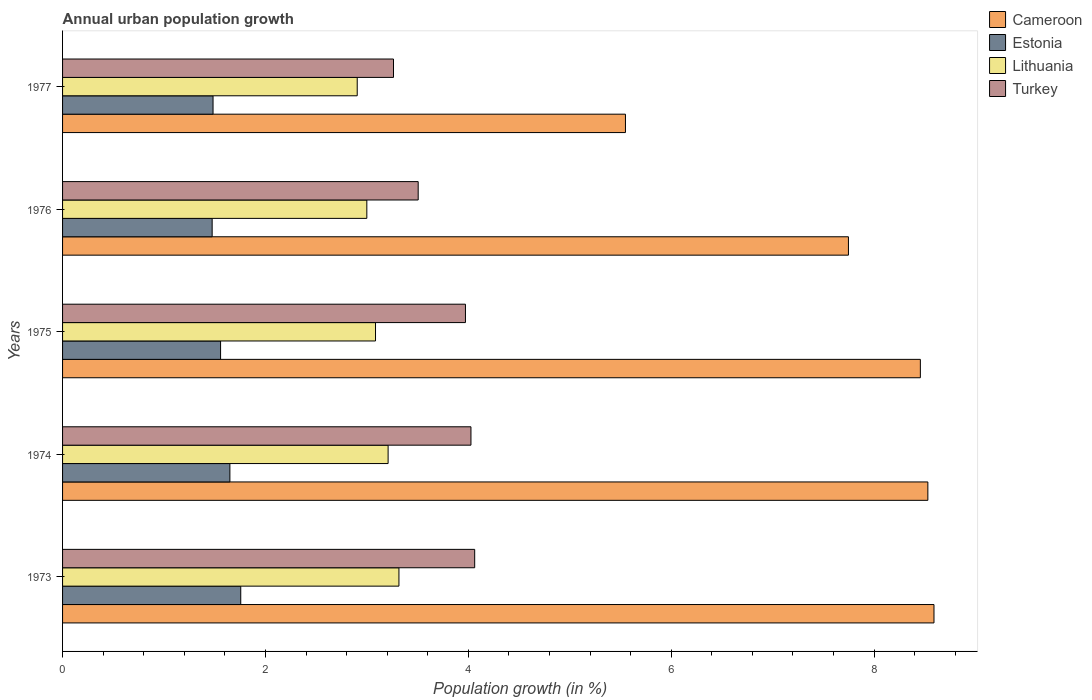How many different coloured bars are there?
Provide a short and direct response. 4. How many groups of bars are there?
Your answer should be very brief. 5. Are the number of bars per tick equal to the number of legend labels?
Your answer should be compact. Yes. How many bars are there on the 3rd tick from the top?
Your answer should be compact. 4. How many bars are there on the 4th tick from the bottom?
Ensure brevity in your answer.  4. What is the label of the 5th group of bars from the top?
Your answer should be compact. 1973. What is the percentage of urban population growth in Estonia in 1976?
Your response must be concise. 1.47. Across all years, what is the maximum percentage of urban population growth in Estonia?
Give a very brief answer. 1.76. Across all years, what is the minimum percentage of urban population growth in Lithuania?
Offer a very short reply. 2.9. In which year was the percentage of urban population growth in Turkey maximum?
Provide a short and direct response. 1973. What is the total percentage of urban population growth in Lithuania in the graph?
Offer a terse response. 15.52. What is the difference between the percentage of urban population growth in Cameroon in 1976 and that in 1977?
Your answer should be compact. 2.2. What is the difference between the percentage of urban population growth in Estonia in 1977 and the percentage of urban population growth in Turkey in 1975?
Your answer should be very brief. -2.49. What is the average percentage of urban population growth in Lithuania per year?
Ensure brevity in your answer.  3.1. In the year 1975, what is the difference between the percentage of urban population growth in Lithuania and percentage of urban population growth in Cameroon?
Your answer should be very brief. -5.37. In how many years, is the percentage of urban population growth in Lithuania greater than 2.4 %?
Offer a terse response. 5. What is the ratio of the percentage of urban population growth in Lithuania in 1974 to that in 1976?
Your response must be concise. 1.07. Is the percentage of urban population growth in Lithuania in 1975 less than that in 1977?
Your answer should be very brief. No. What is the difference between the highest and the second highest percentage of urban population growth in Estonia?
Keep it short and to the point. 0.11. What is the difference between the highest and the lowest percentage of urban population growth in Cameroon?
Keep it short and to the point. 3.04. In how many years, is the percentage of urban population growth in Lithuania greater than the average percentage of urban population growth in Lithuania taken over all years?
Your response must be concise. 2. Is the sum of the percentage of urban population growth in Lithuania in 1975 and 1977 greater than the maximum percentage of urban population growth in Turkey across all years?
Offer a terse response. Yes. Is it the case that in every year, the sum of the percentage of urban population growth in Lithuania and percentage of urban population growth in Cameroon is greater than the sum of percentage of urban population growth in Estonia and percentage of urban population growth in Turkey?
Offer a very short reply. No. What does the 3rd bar from the top in 1975 represents?
Provide a short and direct response. Estonia. What does the 1st bar from the bottom in 1974 represents?
Your answer should be compact. Cameroon. How many bars are there?
Keep it short and to the point. 20. Does the graph contain grids?
Ensure brevity in your answer.  No. What is the title of the graph?
Keep it short and to the point. Annual urban population growth. Does "Luxembourg" appear as one of the legend labels in the graph?
Ensure brevity in your answer.  No. What is the label or title of the X-axis?
Keep it short and to the point. Population growth (in %). What is the label or title of the Y-axis?
Give a very brief answer. Years. What is the Population growth (in %) in Cameroon in 1973?
Keep it short and to the point. 8.59. What is the Population growth (in %) in Estonia in 1973?
Provide a succinct answer. 1.76. What is the Population growth (in %) in Lithuania in 1973?
Offer a very short reply. 3.32. What is the Population growth (in %) in Turkey in 1973?
Offer a terse response. 4.06. What is the Population growth (in %) of Cameroon in 1974?
Your answer should be compact. 8.53. What is the Population growth (in %) in Estonia in 1974?
Provide a succinct answer. 1.65. What is the Population growth (in %) of Lithuania in 1974?
Provide a succinct answer. 3.21. What is the Population growth (in %) in Turkey in 1974?
Ensure brevity in your answer.  4.03. What is the Population growth (in %) in Cameroon in 1975?
Make the answer very short. 8.46. What is the Population growth (in %) of Estonia in 1975?
Provide a succinct answer. 1.56. What is the Population growth (in %) in Lithuania in 1975?
Give a very brief answer. 3.09. What is the Population growth (in %) of Turkey in 1975?
Keep it short and to the point. 3.97. What is the Population growth (in %) of Cameroon in 1976?
Provide a short and direct response. 7.75. What is the Population growth (in %) of Estonia in 1976?
Make the answer very short. 1.47. What is the Population growth (in %) of Lithuania in 1976?
Provide a succinct answer. 3. What is the Population growth (in %) of Turkey in 1976?
Your response must be concise. 3.51. What is the Population growth (in %) of Cameroon in 1977?
Offer a terse response. 5.55. What is the Population growth (in %) in Estonia in 1977?
Make the answer very short. 1.48. What is the Population growth (in %) of Lithuania in 1977?
Ensure brevity in your answer.  2.9. What is the Population growth (in %) in Turkey in 1977?
Offer a very short reply. 3.26. Across all years, what is the maximum Population growth (in %) of Cameroon?
Make the answer very short. 8.59. Across all years, what is the maximum Population growth (in %) of Estonia?
Offer a terse response. 1.76. Across all years, what is the maximum Population growth (in %) of Lithuania?
Provide a short and direct response. 3.32. Across all years, what is the maximum Population growth (in %) of Turkey?
Your answer should be compact. 4.06. Across all years, what is the minimum Population growth (in %) of Cameroon?
Your response must be concise. 5.55. Across all years, what is the minimum Population growth (in %) of Estonia?
Make the answer very short. 1.47. Across all years, what is the minimum Population growth (in %) of Lithuania?
Your response must be concise. 2.9. Across all years, what is the minimum Population growth (in %) of Turkey?
Give a very brief answer. 3.26. What is the total Population growth (in %) of Cameroon in the graph?
Ensure brevity in your answer.  38.87. What is the total Population growth (in %) in Estonia in the graph?
Provide a short and direct response. 7.92. What is the total Population growth (in %) of Lithuania in the graph?
Give a very brief answer. 15.52. What is the total Population growth (in %) in Turkey in the graph?
Give a very brief answer. 18.83. What is the difference between the Population growth (in %) of Cameroon in 1973 and that in 1974?
Offer a terse response. 0.06. What is the difference between the Population growth (in %) in Estonia in 1973 and that in 1974?
Give a very brief answer. 0.11. What is the difference between the Population growth (in %) of Lithuania in 1973 and that in 1974?
Your response must be concise. 0.11. What is the difference between the Population growth (in %) of Turkey in 1973 and that in 1974?
Your answer should be compact. 0.04. What is the difference between the Population growth (in %) of Cameroon in 1973 and that in 1975?
Your answer should be very brief. 0.13. What is the difference between the Population growth (in %) in Estonia in 1973 and that in 1975?
Your answer should be compact. 0.2. What is the difference between the Population growth (in %) in Lithuania in 1973 and that in 1975?
Make the answer very short. 0.23. What is the difference between the Population growth (in %) of Turkey in 1973 and that in 1975?
Offer a terse response. 0.09. What is the difference between the Population growth (in %) in Cameroon in 1973 and that in 1976?
Make the answer very short. 0.84. What is the difference between the Population growth (in %) in Estonia in 1973 and that in 1976?
Your response must be concise. 0.28. What is the difference between the Population growth (in %) in Lithuania in 1973 and that in 1976?
Offer a terse response. 0.32. What is the difference between the Population growth (in %) of Turkey in 1973 and that in 1976?
Keep it short and to the point. 0.56. What is the difference between the Population growth (in %) in Cameroon in 1973 and that in 1977?
Keep it short and to the point. 3.04. What is the difference between the Population growth (in %) of Estonia in 1973 and that in 1977?
Offer a very short reply. 0.27. What is the difference between the Population growth (in %) of Lithuania in 1973 and that in 1977?
Offer a terse response. 0.41. What is the difference between the Population growth (in %) in Turkey in 1973 and that in 1977?
Offer a terse response. 0.8. What is the difference between the Population growth (in %) of Cameroon in 1974 and that in 1975?
Offer a very short reply. 0.07. What is the difference between the Population growth (in %) of Estonia in 1974 and that in 1975?
Offer a very short reply. 0.09. What is the difference between the Population growth (in %) in Lithuania in 1974 and that in 1975?
Provide a short and direct response. 0.12. What is the difference between the Population growth (in %) of Turkey in 1974 and that in 1975?
Make the answer very short. 0.05. What is the difference between the Population growth (in %) of Cameroon in 1974 and that in 1976?
Offer a very short reply. 0.78. What is the difference between the Population growth (in %) of Estonia in 1974 and that in 1976?
Provide a succinct answer. 0.17. What is the difference between the Population growth (in %) in Lithuania in 1974 and that in 1976?
Provide a succinct answer. 0.21. What is the difference between the Population growth (in %) of Turkey in 1974 and that in 1976?
Make the answer very short. 0.52. What is the difference between the Population growth (in %) of Cameroon in 1974 and that in 1977?
Your response must be concise. 2.98. What is the difference between the Population growth (in %) of Estonia in 1974 and that in 1977?
Your response must be concise. 0.17. What is the difference between the Population growth (in %) in Lithuania in 1974 and that in 1977?
Provide a succinct answer. 0.3. What is the difference between the Population growth (in %) of Turkey in 1974 and that in 1977?
Your answer should be very brief. 0.76. What is the difference between the Population growth (in %) in Cameroon in 1975 and that in 1976?
Your answer should be very brief. 0.71. What is the difference between the Population growth (in %) of Estonia in 1975 and that in 1976?
Your response must be concise. 0.08. What is the difference between the Population growth (in %) in Lithuania in 1975 and that in 1976?
Offer a terse response. 0.09. What is the difference between the Population growth (in %) in Turkey in 1975 and that in 1976?
Ensure brevity in your answer.  0.47. What is the difference between the Population growth (in %) in Cameroon in 1975 and that in 1977?
Offer a very short reply. 2.91. What is the difference between the Population growth (in %) of Estonia in 1975 and that in 1977?
Your answer should be very brief. 0.07. What is the difference between the Population growth (in %) of Lithuania in 1975 and that in 1977?
Keep it short and to the point. 0.18. What is the difference between the Population growth (in %) of Turkey in 1975 and that in 1977?
Provide a short and direct response. 0.71. What is the difference between the Population growth (in %) of Cameroon in 1976 and that in 1977?
Provide a short and direct response. 2.2. What is the difference between the Population growth (in %) in Estonia in 1976 and that in 1977?
Give a very brief answer. -0.01. What is the difference between the Population growth (in %) in Lithuania in 1976 and that in 1977?
Offer a very short reply. 0.09. What is the difference between the Population growth (in %) in Turkey in 1976 and that in 1977?
Make the answer very short. 0.24. What is the difference between the Population growth (in %) in Cameroon in 1973 and the Population growth (in %) in Estonia in 1974?
Ensure brevity in your answer.  6.94. What is the difference between the Population growth (in %) of Cameroon in 1973 and the Population growth (in %) of Lithuania in 1974?
Ensure brevity in your answer.  5.38. What is the difference between the Population growth (in %) in Cameroon in 1973 and the Population growth (in %) in Turkey in 1974?
Make the answer very short. 4.56. What is the difference between the Population growth (in %) of Estonia in 1973 and the Population growth (in %) of Lithuania in 1974?
Provide a short and direct response. -1.45. What is the difference between the Population growth (in %) of Estonia in 1973 and the Population growth (in %) of Turkey in 1974?
Provide a short and direct response. -2.27. What is the difference between the Population growth (in %) of Lithuania in 1973 and the Population growth (in %) of Turkey in 1974?
Provide a short and direct response. -0.71. What is the difference between the Population growth (in %) in Cameroon in 1973 and the Population growth (in %) in Estonia in 1975?
Give a very brief answer. 7.03. What is the difference between the Population growth (in %) in Cameroon in 1973 and the Population growth (in %) in Lithuania in 1975?
Offer a terse response. 5.51. What is the difference between the Population growth (in %) in Cameroon in 1973 and the Population growth (in %) in Turkey in 1975?
Give a very brief answer. 4.62. What is the difference between the Population growth (in %) of Estonia in 1973 and the Population growth (in %) of Lithuania in 1975?
Give a very brief answer. -1.33. What is the difference between the Population growth (in %) of Estonia in 1973 and the Population growth (in %) of Turkey in 1975?
Offer a terse response. -2.22. What is the difference between the Population growth (in %) in Lithuania in 1973 and the Population growth (in %) in Turkey in 1975?
Your answer should be very brief. -0.66. What is the difference between the Population growth (in %) of Cameroon in 1973 and the Population growth (in %) of Estonia in 1976?
Your answer should be compact. 7.12. What is the difference between the Population growth (in %) of Cameroon in 1973 and the Population growth (in %) of Lithuania in 1976?
Your answer should be very brief. 5.59. What is the difference between the Population growth (in %) of Cameroon in 1973 and the Population growth (in %) of Turkey in 1976?
Offer a terse response. 5.08. What is the difference between the Population growth (in %) in Estonia in 1973 and the Population growth (in %) in Lithuania in 1976?
Ensure brevity in your answer.  -1.24. What is the difference between the Population growth (in %) in Estonia in 1973 and the Population growth (in %) in Turkey in 1976?
Make the answer very short. -1.75. What is the difference between the Population growth (in %) of Lithuania in 1973 and the Population growth (in %) of Turkey in 1976?
Make the answer very short. -0.19. What is the difference between the Population growth (in %) in Cameroon in 1973 and the Population growth (in %) in Estonia in 1977?
Provide a succinct answer. 7.11. What is the difference between the Population growth (in %) in Cameroon in 1973 and the Population growth (in %) in Lithuania in 1977?
Your answer should be very brief. 5.69. What is the difference between the Population growth (in %) of Cameroon in 1973 and the Population growth (in %) of Turkey in 1977?
Make the answer very short. 5.33. What is the difference between the Population growth (in %) in Estonia in 1973 and the Population growth (in %) in Lithuania in 1977?
Your answer should be compact. -1.15. What is the difference between the Population growth (in %) of Estonia in 1973 and the Population growth (in %) of Turkey in 1977?
Keep it short and to the point. -1.51. What is the difference between the Population growth (in %) in Lithuania in 1973 and the Population growth (in %) in Turkey in 1977?
Keep it short and to the point. 0.05. What is the difference between the Population growth (in %) in Cameroon in 1974 and the Population growth (in %) in Estonia in 1975?
Keep it short and to the point. 6.97. What is the difference between the Population growth (in %) of Cameroon in 1974 and the Population growth (in %) of Lithuania in 1975?
Your answer should be compact. 5.45. What is the difference between the Population growth (in %) of Cameroon in 1974 and the Population growth (in %) of Turkey in 1975?
Your answer should be very brief. 4.56. What is the difference between the Population growth (in %) of Estonia in 1974 and the Population growth (in %) of Lithuania in 1975?
Provide a short and direct response. -1.44. What is the difference between the Population growth (in %) of Estonia in 1974 and the Population growth (in %) of Turkey in 1975?
Offer a very short reply. -2.32. What is the difference between the Population growth (in %) of Lithuania in 1974 and the Population growth (in %) of Turkey in 1975?
Provide a short and direct response. -0.76. What is the difference between the Population growth (in %) in Cameroon in 1974 and the Population growth (in %) in Estonia in 1976?
Ensure brevity in your answer.  7.06. What is the difference between the Population growth (in %) in Cameroon in 1974 and the Population growth (in %) in Lithuania in 1976?
Offer a terse response. 5.53. What is the difference between the Population growth (in %) of Cameroon in 1974 and the Population growth (in %) of Turkey in 1976?
Make the answer very short. 5.02. What is the difference between the Population growth (in %) in Estonia in 1974 and the Population growth (in %) in Lithuania in 1976?
Provide a short and direct response. -1.35. What is the difference between the Population growth (in %) of Estonia in 1974 and the Population growth (in %) of Turkey in 1976?
Your answer should be very brief. -1.86. What is the difference between the Population growth (in %) of Lithuania in 1974 and the Population growth (in %) of Turkey in 1976?
Make the answer very short. -0.3. What is the difference between the Population growth (in %) of Cameroon in 1974 and the Population growth (in %) of Estonia in 1977?
Offer a terse response. 7.05. What is the difference between the Population growth (in %) of Cameroon in 1974 and the Population growth (in %) of Lithuania in 1977?
Your answer should be very brief. 5.63. What is the difference between the Population growth (in %) of Cameroon in 1974 and the Population growth (in %) of Turkey in 1977?
Your answer should be compact. 5.27. What is the difference between the Population growth (in %) in Estonia in 1974 and the Population growth (in %) in Lithuania in 1977?
Keep it short and to the point. -1.26. What is the difference between the Population growth (in %) of Estonia in 1974 and the Population growth (in %) of Turkey in 1977?
Offer a terse response. -1.61. What is the difference between the Population growth (in %) in Lithuania in 1974 and the Population growth (in %) in Turkey in 1977?
Keep it short and to the point. -0.05. What is the difference between the Population growth (in %) of Cameroon in 1975 and the Population growth (in %) of Estonia in 1976?
Your answer should be compact. 6.98. What is the difference between the Population growth (in %) of Cameroon in 1975 and the Population growth (in %) of Lithuania in 1976?
Ensure brevity in your answer.  5.46. What is the difference between the Population growth (in %) of Cameroon in 1975 and the Population growth (in %) of Turkey in 1976?
Offer a very short reply. 4.95. What is the difference between the Population growth (in %) of Estonia in 1975 and the Population growth (in %) of Lithuania in 1976?
Keep it short and to the point. -1.44. What is the difference between the Population growth (in %) in Estonia in 1975 and the Population growth (in %) in Turkey in 1976?
Provide a short and direct response. -1.95. What is the difference between the Population growth (in %) of Lithuania in 1975 and the Population growth (in %) of Turkey in 1976?
Your answer should be very brief. -0.42. What is the difference between the Population growth (in %) in Cameroon in 1975 and the Population growth (in %) in Estonia in 1977?
Your answer should be very brief. 6.97. What is the difference between the Population growth (in %) in Cameroon in 1975 and the Population growth (in %) in Lithuania in 1977?
Make the answer very short. 5.55. What is the difference between the Population growth (in %) of Cameroon in 1975 and the Population growth (in %) of Turkey in 1977?
Offer a terse response. 5.19. What is the difference between the Population growth (in %) of Estonia in 1975 and the Population growth (in %) of Lithuania in 1977?
Offer a very short reply. -1.35. What is the difference between the Population growth (in %) in Estonia in 1975 and the Population growth (in %) in Turkey in 1977?
Your answer should be very brief. -1.7. What is the difference between the Population growth (in %) in Lithuania in 1975 and the Population growth (in %) in Turkey in 1977?
Offer a terse response. -0.18. What is the difference between the Population growth (in %) in Cameroon in 1976 and the Population growth (in %) in Estonia in 1977?
Provide a succinct answer. 6.26. What is the difference between the Population growth (in %) of Cameroon in 1976 and the Population growth (in %) of Lithuania in 1977?
Provide a succinct answer. 4.84. What is the difference between the Population growth (in %) of Cameroon in 1976 and the Population growth (in %) of Turkey in 1977?
Provide a short and direct response. 4.49. What is the difference between the Population growth (in %) in Estonia in 1976 and the Population growth (in %) in Lithuania in 1977?
Your answer should be very brief. -1.43. What is the difference between the Population growth (in %) in Estonia in 1976 and the Population growth (in %) in Turkey in 1977?
Provide a succinct answer. -1.79. What is the difference between the Population growth (in %) of Lithuania in 1976 and the Population growth (in %) of Turkey in 1977?
Ensure brevity in your answer.  -0.26. What is the average Population growth (in %) of Cameroon per year?
Offer a very short reply. 7.78. What is the average Population growth (in %) of Estonia per year?
Your answer should be very brief. 1.58. What is the average Population growth (in %) of Lithuania per year?
Your answer should be very brief. 3.1. What is the average Population growth (in %) in Turkey per year?
Your answer should be compact. 3.77. In the year 1973, what is the difference between the Population growth (in %) in Cameroon and Population growth (in %) in Estonia?
Provide a succinct answer. 6.83. In the year 1973, what is the difference between the Population growth (in %) in Cameroon and Population growth (in %) in Lithuania?
Provide a short and direct response. 5.27. In the year 1973, what is the difference between the Population growth (in %) in Cameroon and Population growth (in %) in Turkey?
Offer a terse response. 4.53. In the year 1973, what is the difference between the Population growth (in %) of Estonia and Population growth (in %) of Lithuania?
Provide a succinct answer. -1.56. In the year 1973, what is the difference between the Population growth (in %) in Estonia and Population growth (in %) in Turkey?
Give a very brief answer. -2.31. In the year 1973, what is the difference between the Population growth (in %) in Lithuania and Population growth (in %) in Turkey?
Provide a succinct answer. -0.75. In the year 1974, what is the difference between the Population growth (in %) in Cameroon and Population growth (in %) in Estonia?
Provide a short and direct response. 6.88. In the year 1974, what is the difference between the Population growth (in %) of Cameroon and Population growth (in %) of Lithuania?
Your answer should be very brief. 5.32. In the year 1974, what is the difference between the Population growth (in %) in Cameroon and Population growth (in %) in Turkey?
Give a very brief answer. 4.5. In the year 1974, what is the difference between the Population growth (in %) of Estonia and Population growth (in %) of Lithuania?
Make the answer very short. -1.56. In the year 1974, what is the difference between the Population growth (in %) of Estonia and Population growth (in %) of Turkey?
Your answer should be very brief. -2.38. In the year 1974, what is the difference between the Population growth (in %) of Lithuania and Population growth (in %) of Turkey?
Provide a succinct answer. -0.82. In the year 1975, what is the difference between the Population growth (in %) in Cameroon and Population growth (in %) in Estonia?
Provide a succinct answer. 6.9. In the year 1975, what is the difference between the Population growth (in %) of Cameroon and Population growth (in %) of Lithuania?
Provide a succinct answer. 5.37. In the year 1975, what is the difference between the Population growth (in %) in Cameroon and Population growth (in %) in Turkey?
Make the answer very short. 4.48. In the year 1975, what is the difference between the Population growth (in %) in Estonia and Population growth (in %) in Lithuania?
Offer a terse response. -1.53. In the year 1975, what is the difference between the Population growth (in %) of Estonia and Population growth (in %) of Turkey?
Give a very brief answer. -2.41. In the year 1975, what is the difference between the Population growth (in %) in Lithuania and Population growth (in %) in Turkey?
Offer a very short reply. -0.89. In the year 1976, what is the difference between the Population growth (in %) in Cameroon and Population growth (in %) in Estonia?
Your answer should be very brief. 6.27. In the year 1976, what is the difference between the Population growth (in %) of Cameroon and Population growth (in %) of Lithuania?
Provide a succinct answer. 4.75. In the year 1976, what is the difference between the Population growth (in %) in Cameroon and Population growth (in %) in Turkey?
Your response must be concise. 4.24. In the year 1976, what is the difference between the Population growth (in %) of Estonia and Population growth (in %) of Lithuania?
Your answer should be compact. -1.52. In the year 1976, what is the difference between the Population growth (in %) of Estonia and Population growth (in %) of Turkey?
Make the answer very short. -2.03. In the year 1976, what is the difference between the Population growth (in %) of Lithuania and Population growth (in %) of Turkey?
Make the answer very short. -0.51. In the year 1977, what is the difference between the Population growth (in %) of Cameroon and Population growth (in %) of Estonia?
Make the answer very short. 4.07. In the year 1977, what is the difference between the Population growth (in %) of Cameroon and Population growth (in %) of Lithuania?
Provide a short and direct response. 2.64. In the year 1977, what is the difference between the Population growth (in %) of Cameroon and Population growth (in %) of Turkey?
Provide a succinct answer. 2.29. In the year 1977, what is the difference between the Population growth (in %) of Estonia and Population growth (in %) of Lithuania?
Your answer should be very brief. -1.42. In the year 1977, what is the difference between the Population growth (in %) of Estonia and Population growth (in %) of Turkey?
Offer a very short reply. -1.78. In the year 1977, what is the difference between the Population growth (in %) in Lithuania and Population growth (in %) in Turkey?
Offer a very short reply. -0.36. What is the ratio of the Population growth (in %) of Cameroon in 1973 to that in 1974?
Make the answer very short. 1.01. What is the ratio of the Population growth (in %) of Estonia in 1973 to that in 1974?
Provide a short and direct response. 1.06. What is the ratio of the Population growth (in %) in Turkey in 1973 to that in 1974?
Ensure brevity in your answer.  1.01. What is the ratio of the Population growth (in %) in Cameroon in 1973 to that in 1975?
Give a very brief answer. 1.02. What is the ratio of the Population growth (in %) of Estonia in 1973 to that in 1975?
Make the answer very short. 1.13. What is the ratio of the Population growth (in %) of Lithuania in 1973 to that in 1975?
Keep it short and to the point. 1.07. What is the ratio of the Population growth (in %) of Turkey in 1973 to that in 1975?
Your response must be concise. 1.02. What is the ratio of the Population growth (in %) in Cameroon in 1973 to that in 1976?
Offer a terse response. 1.11. What is the ratio of the Population growth (in %) of Estonia in 1973 to that in 1976?
Offer a very short reply. 1.19. What is the ratio of the Population growth (in %) in Lithuania in 1973 to that in 1976?
Make the answer very short. 1.11. What is the ratio of the Population growth (in %) in Turkey in 1973 to that in 1976?
Ensure brevity in your answer.  1.16. What is the ratio of the Population growth (in %) of Cameroon in 1973 to that in 1977?
Your response must be concise. 1.55. What is the ratio of the Population growth (in %) in Estonia in 1973 to that in 1977?
Your answer should be compact. 1.18. What is the ratio of the Population growth (in %) in Lithuania in 1973 to that in 1977?
Give a very brief answer. 1.14. What is the ratio of the Population growth (in %) of Turkey in 1973 to that in 1977?
Give a very brief answer. 1.25. What is the ratio of the Population growth (in %) of Cameroon in 1974 to that in 1975?
Keep it short and to the point. 1.01. What is the ratio of the Population growth (in %) of Estonia in 1974 to that in 1975?
Offer a very short reply. 1.06. What is the ratio of the Population growth (in %) in Lithuania in 1974 to that in 1975?
Your answer should be very brief. 1.04. What is the ratio of the Population growth (in %) in Turkey in 1974 to that in 1975?
Ensure brevity in your answer.  1.01. What is the ratio of the Population growth (in %) in Cameroon in 1974 to that in 1976?
Provide a short and direct response. 1.1. What is the ratio of the Population growth (in %) in Estonia in 1974 to that in 1976?
Give a very brief answer. 1.12. What is the ratio of the Population growth (in %) in Lithuania in 1974 to that in 1976?
Your answer should be compact. 1.07. What is the ratio of the Population growth (in %) in Turkey in 1974 to that in 1976?
Your response must be concise. 1.15. What is the ratio of the Population growth (in %) of Cameroon in 1974 to that in 1977?
Give a very brief answer. 1.54. What is the ratio of the Population growth (in %) of Estonia in 1974 to that in 1977?
Provide a short and direct response. 1.11. What is the ratio of the Population growth (in %) in Lithuania in 1974 to that in 1977?
Give a very brief answer. 1.1. What is the ratio of the Population growth (in %) of Turkey in 1974 to that in 1977?
Give a very brief answer. 1.23. What is the ratio of the Population growth (in %) in Cameroon in 1975 to that in 1976?
Your answer should be compact. 1.09. What is the ratio of the Population growth (in %) in Estonia in 1975 to that in 1976?
Your answer should be very brief. 1.06. What is the ratio of the Population growth (in %) in Lithuania in 1975 to that in 1976?
Your answer should be compact. 1.03. What is the ratio of the Population growth (in %) of Turkey in 1975 to that in 1976?
Ensure brevity in your answer.  1.13. What is the ratio of the Population growth (in %) in Cameroon in 1975 to that in 1977?
Ensure brevity in your answer.  1.52. What is the ratio of the Population growth (in %) of Estonia in 1975 to that in 1977?
Offer a very short reply. 1.05. What is the ratio of the Population growth (in %) in Lithuania in 1975 to that in 1977?
Provide a succinct answer. 1.06. What is the ratio of the Population growth (in %) of Turkey in 1975 to that in 1977?
Provide a short and direct response. 1.22. What is the ratio of the Population growth (in %) in Cameroon in 1976 to that in 1977?
Your answer should be very brief. 1.4. What is the ratio of the Population growth (in %) of Estonia in 1976 to that in 1977?
Ensure brevity in your answer.  0.99. What is the ratio of the Population growth (in %) of Lithuania in 1976 to that in 1977?
Keep it short and to the point. 1.03. What is the ratio of the Population growth (in %) in Turkey in 1976 to that in 1977?
Ensure brevity in your answer.  1.07. What is the difference between the highest and the second highest Population growth (in %) in Cameroon?
Offer a terse response. 0.06. What is the difference between the highest and the second highest Population growth (in %) of Estonia?
Make the answer very short. 0.11. What is the difference between the highest and the second highest Population growth (in %) of Lithuania?
Your response must be concise. 0.11. What is the difference between the highest and the second highest Population growth (in %) of Turkey?
Provide a short and direct response. 0.04. What is the difference between the highest and the lowest Population growth (in %) of Cameroon?
Provide a short and direct response. 3.04. What is the difference between the highest and the lowest Population growth (in %) in Estonia?
Your answer should be very brief. 0.28. What is the difference between the highest and the lowest Population growth (in %) in Lithuania?
Provide a short and direct response. 0.41. What is the difference between the highest and the lowest Population growth (in %) in Turkey?
Your answer should be compact. 0.8. 